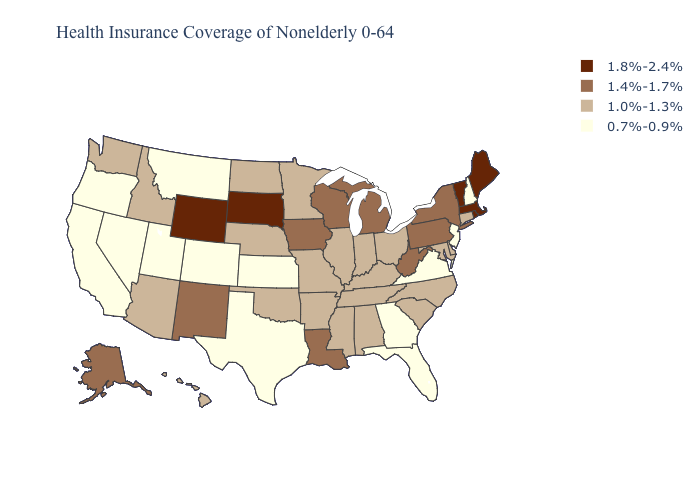Does Arkansas have the highest value in the USA?
Quick response, please. No. Does the map have missing data?
Concise answer only. No. What is the highest value in the USA?
Short answer required. 1.8%-2.4%. Among the states that border Colorado , does Wyoming have the highest value?
Be succinct. Yes. Does the map have missing data?
Give a very brief answer. No. Does Illinois have the highest value in the USA?
Quick response, please. No. Does North Dakota have the lowest value in the USA?
Keep it brief. No. What is the value of Ohio?
Quick response, please. 1.0%-1.3%. Which states have the lowest value in the MidWest?
Answer briefly. Kansas. What is the highest value in states that border New Jersey?
Give a very brief answer. 1.4%-1.7%. Which states have the lowest value in the Northeast?
Keep it brief. New Hampshire, New Jersey. What is the value of Oregon?
Keep it brief. 0.7%-0.9%. What is the highest value in the Northeast ?
Be succinct. 1.8%-2.4%. Does the first symbol in the legend represent the smallest category?
Be succinct. No. Does Colorado have the lowest value in the USA?
Concise answer only. Yes. 